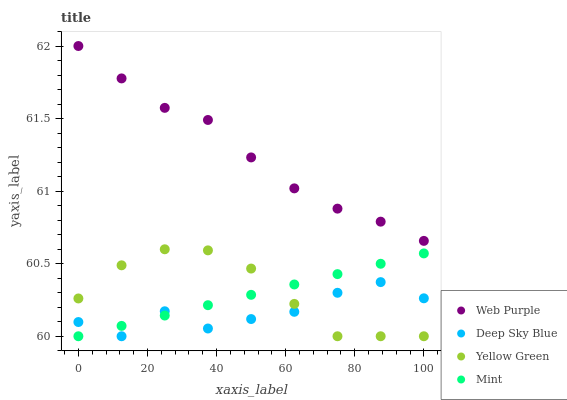Does Deep Sky Blue have the minimum area under the curve?
Answer yes or no. Yes. Does Web Purple have the maximum area under the curve?
Answer yes or no. Yes. Does Mint have the minimum area under the curve?
Answer yes or no. No. Does Mint have the maximum area under the curve?
Answer yes or no. No. Is Mint the smoothest?
Answer yes or no. Yes. Is Deep Sky Blue the roughest?
Answer yes or no. Yes. Is Yellow Green the smoothest?
Answer yes or no. No. Is Yellow Green the roughest?
Answer yes or no. No. Does Mint have the lowest value?
Answer yes or no. Yes. Does Web Purple have the highest value?
Answer yes or no. Yes. Does Mint have the highest value?
Answer yes or no. No. Is Mint less than Web Purple?
Answer yes or no. Yes. Is Web Purple greater than Deep Sky Blue?
Answer yes or no. Yes. Does Mint intersect Yellow Green?
Answer yes or no. Yes. Is Mint less than Yellow Green?
Answer yes or no. No. Is Mint greater than Yellow Green?
Answer yes or no. No. Does Mint intersect Web Purple?
Answer yes or no. No. 